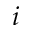Convert formula to latex. <formula><loc_0><loc_0><loc_500><loc_500>i</formula> 